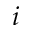Convert formula to latex. <formula><loc_0><loc_0><loc_500><loc_500>i</formula> 